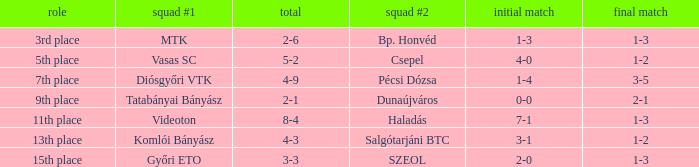Parse the full table. {'header': ['role', 'squad #1', 'total', 'squad #2', 'initial match', 'final match'], 'rows': [['3rd place', 'MTK', '2-6', 'Bp. Honvéd', '1-3', '1-3'], ['5th place', 'Vasas SC', '5-2', 'Csepel', '4-0', '1-2'], ['7th place', 'Diósgyőri VTK', '4-9', 'Pécsi Dózsa', '1-4', '3-5'], ['9th place', 'Tatabányai Bányász', '2-1', 'Dunaújváros', '0-0', '2-1'], ['11th place', 'Videoton', '8-4', 'Haladás', '7-1', '1-3'], ['13th place', 'Komlói Bányász', '4-3', 'Salgótarjáni BTC', '3-1', '1-2'], ['15th place', 'Győri ETO', '3-3', 'SZEOL', '2-0', '1-3']]} What is the 1st leg with a 4-3 agg.? 3-1. 